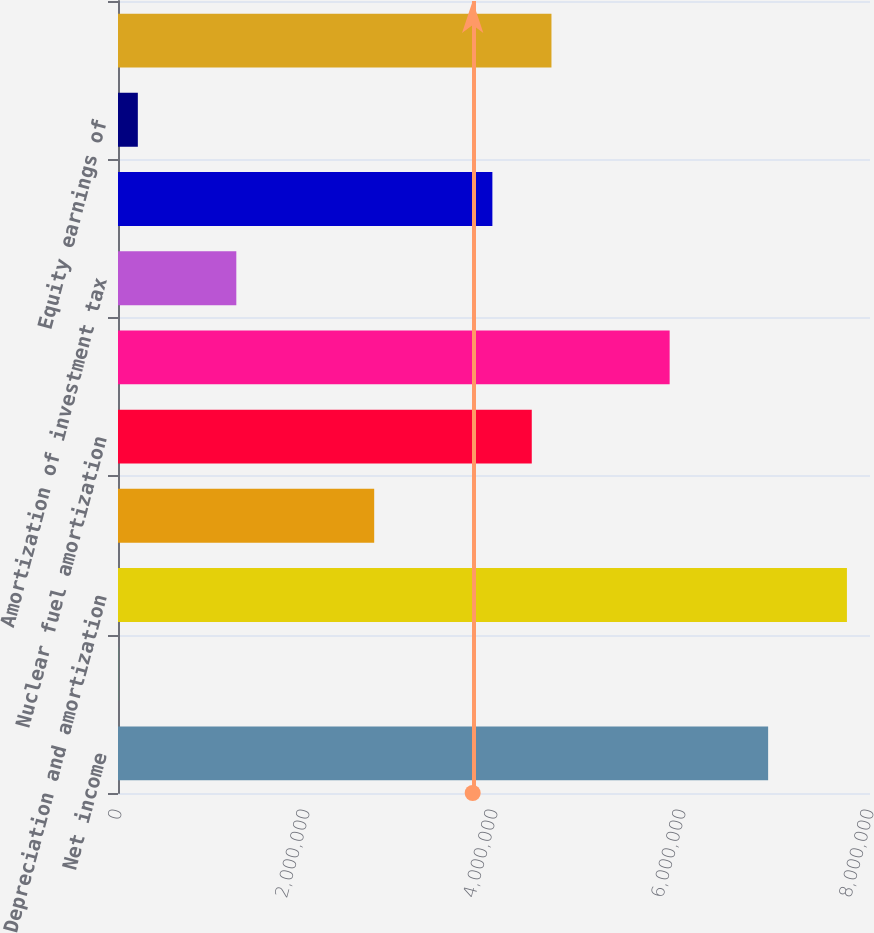Convert chart to OTSL. <chart><loc_0><loc_0><loc_500><loc_500><bar_chart><fcel>Net income<fcel>Remove loss (income) from<fcel>Depreciation and amortization<fcel>Conservation and demand side<fcel>Nuclear fuel amortization<fcel>Deferred income taxes<fcel>Amortization of investment tax<fcel>Allowance for equity funds<fcel>Equity earnings of<fcel>Provision for bad debts<nl><fcel>6.9163e+06<fcel>1449<fcel>7.75446e+06<fcel>2.72548e+06<fcel>4.40181e+06<fcel>5.86859e+06<fcel>1.25869e+06<fcel>3.98272e+06<fcel>210990<fcel>4.61135e+06<nl></chart> 